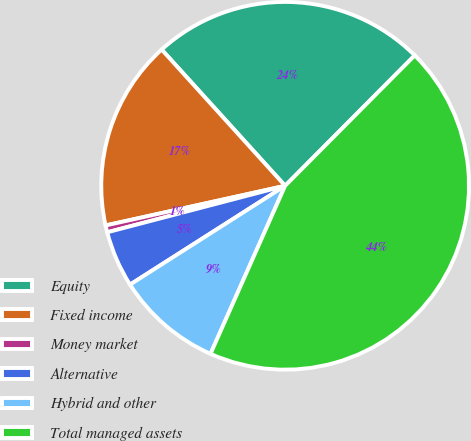Convert chart. <chart><loc_0><loc_0><loc_500><loc_500><pie_chart><fcel>Equity<fcel>Fixed income<fcel>Money market<fcel>Alternative<fcel>Hybrid and other<fcel>Total managed assets<nl><fcel>24.17%<fcel>16.74%<fcel>0.61%<fcel>4.96%<fcel>9.32%<fcel>44.2%<nl></chart> 